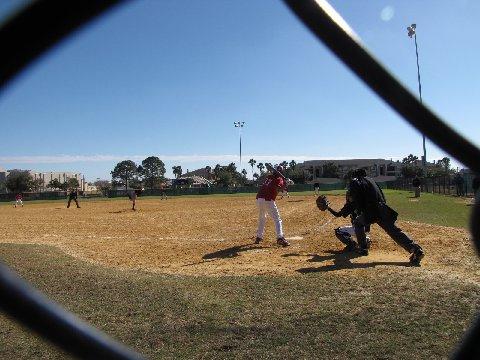How many buildings are in the picture?
Give a very brief answer. 2. What is in the man's hands?
Concise answer only. Glove. Where are the people playing?
Answer briefly. Baseball field. Is the camera person taking the photo through a chain link fence?
Answer briefly. Yes. 